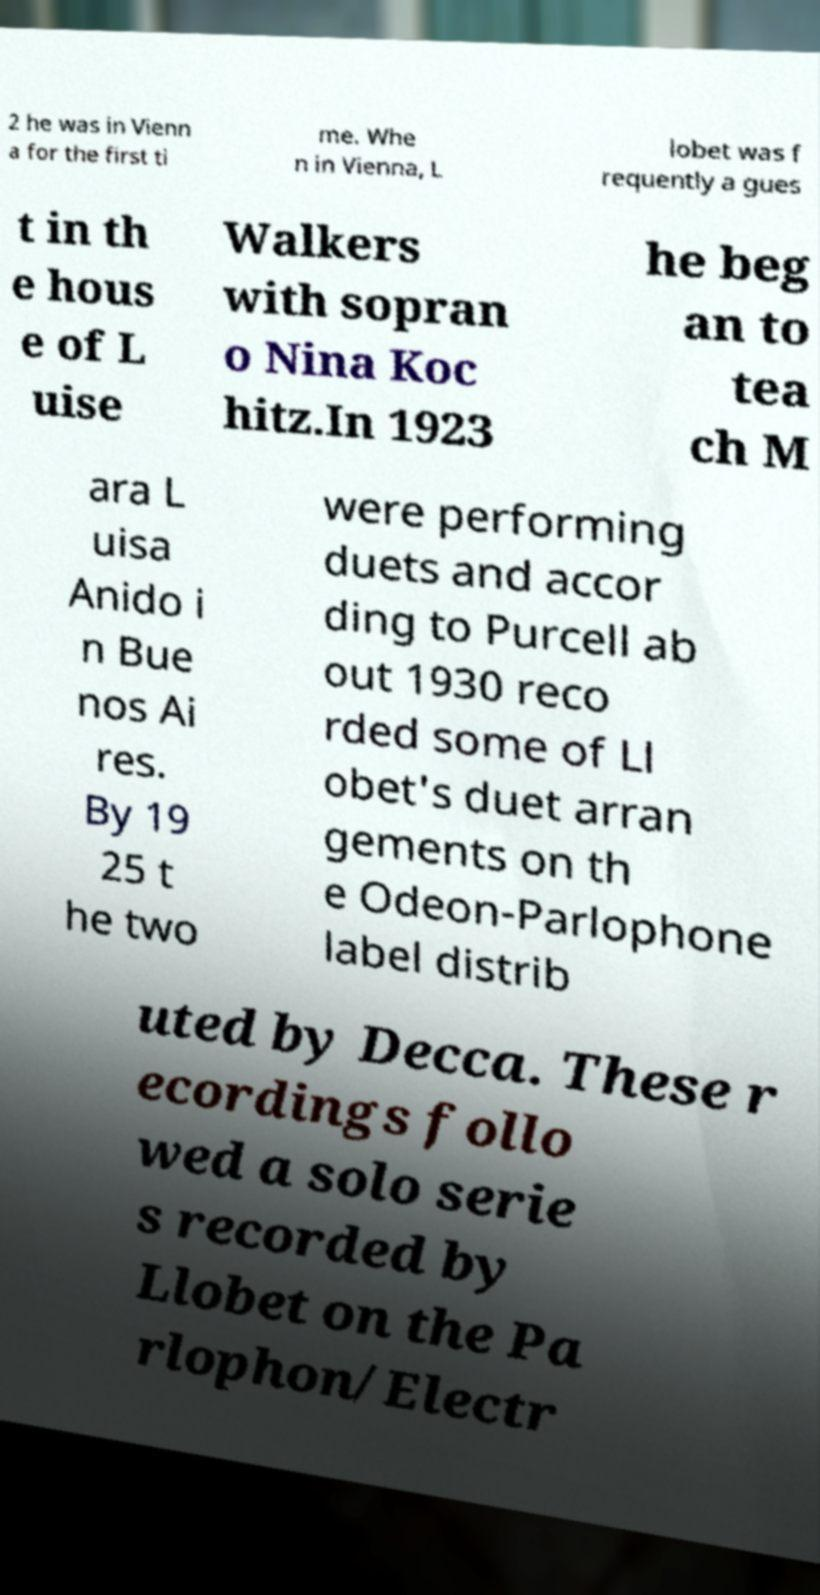I need the written content from this picture converted into text. Can you do that? 2 he was in Vienn a for the first ti me. Whe n in Vienna, L lobet was f requently a gues t in th e hous e of L uise Walkers with sopran o Nina Koc hitz.In 1923 he beg an to tea ch M ara L uisa Anido i n Bue nos Ai res. By 19 25 t he two were performing duets and accor ding to Purcell ab out 1930 reco rded some of Ll obet's duet arran gements on th e Odeon-Parlophone label distrib uted by Decca. These r ecordings follo wed a solo serie s recorded by Llobet on the Pa rlophon/Electr 